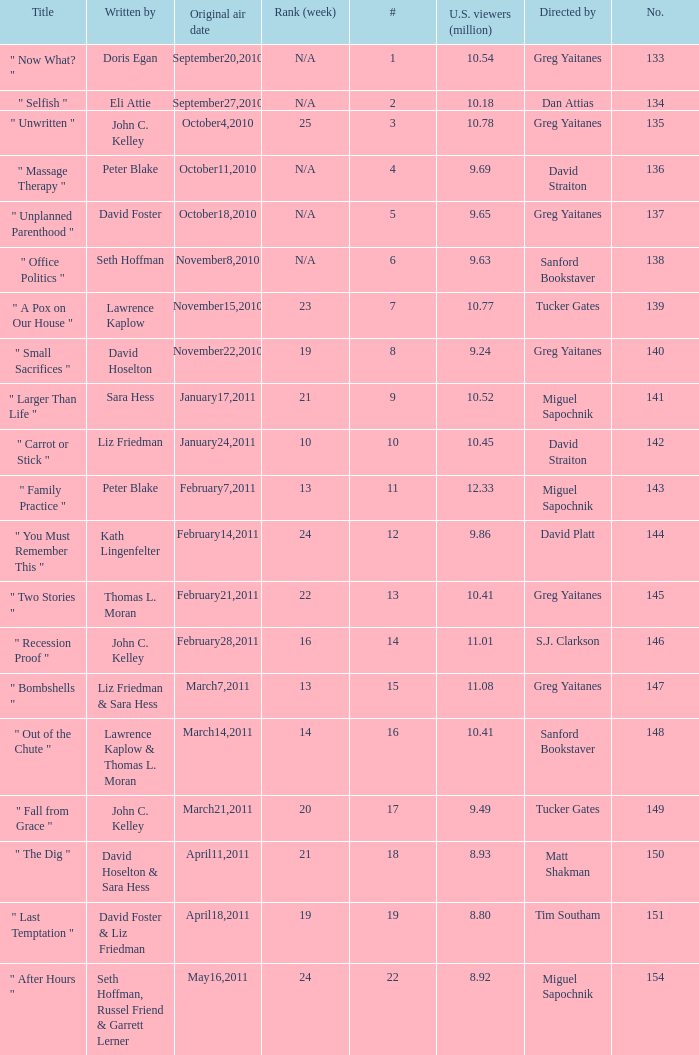How many episodes were written by seth hoffman, russel friend & garrett lerner? 1.0. 